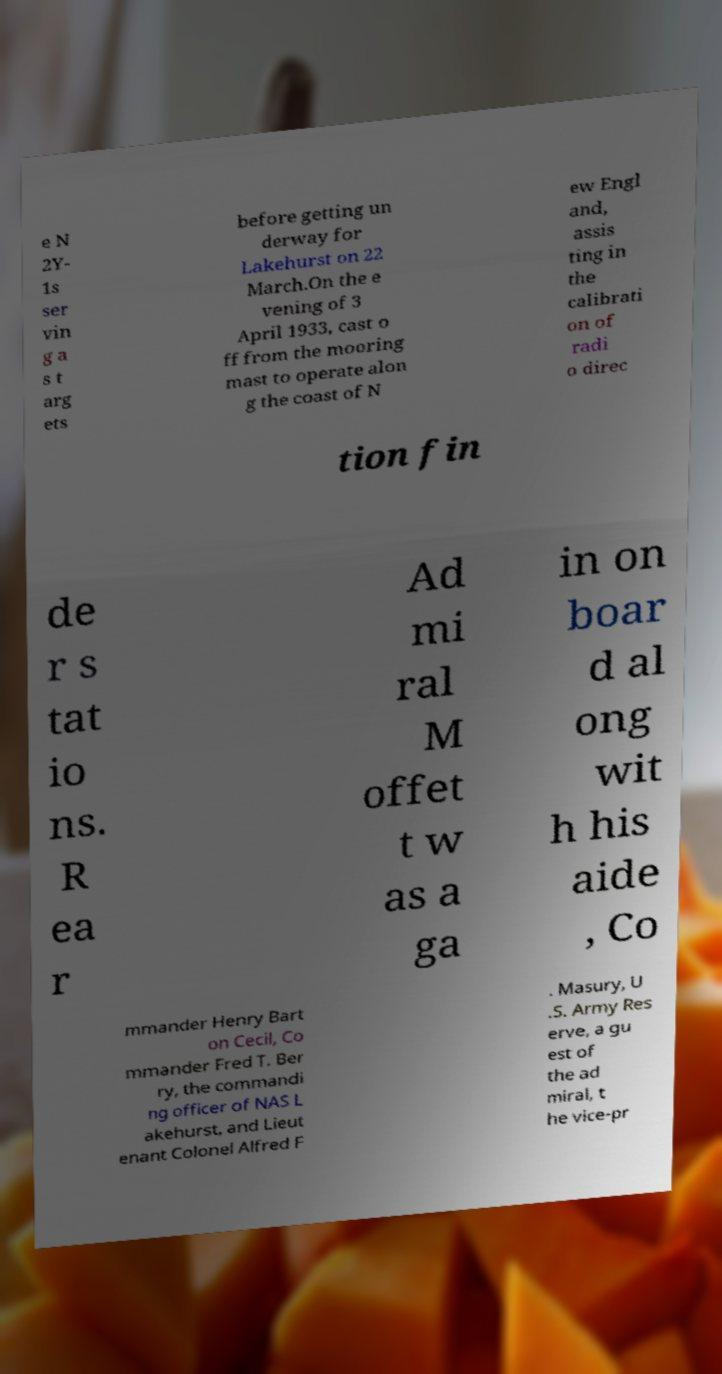Could you extract and type out the text from this image? e N 2Y- 1s ser vin g a s t arg ets before getting un derway for Lakehurst on 22 March.On the e vening of 3 April 1933, cast o ff from the mooring mast to operate alon g the coast of N ew Engl and, assis ting in the calibrati on of radi o direc tion fin de r s tat io ns. R ea r Ad mi ral M offet t w as a ga in on boar d al ong wit h his aide , Co mmander Henry Bart on Cecil, Co mmander Fred T. Ber ry, the commandi ng officer of NAS L akehurst, and Lieut enant Colonel Alfred F . Masury, U .S. Army Res erve, a gu est of the ad miral, t he vice-pr 